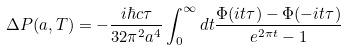<formula> <loc_0><loc_0><loc_500><loc_500>\Delta { P } ( a , T ) = - \frac { i \hbar { c } \tau } { 3 2 \pi ^ { 2 } a ^ { 4 } } \int _ { 0 } ^ { \infty } d t \frac { \Phi ( i t \tau ) - \Phi ( - i t \tau ) } { e ^ { 2 \pi t } - 1 }</formula> 